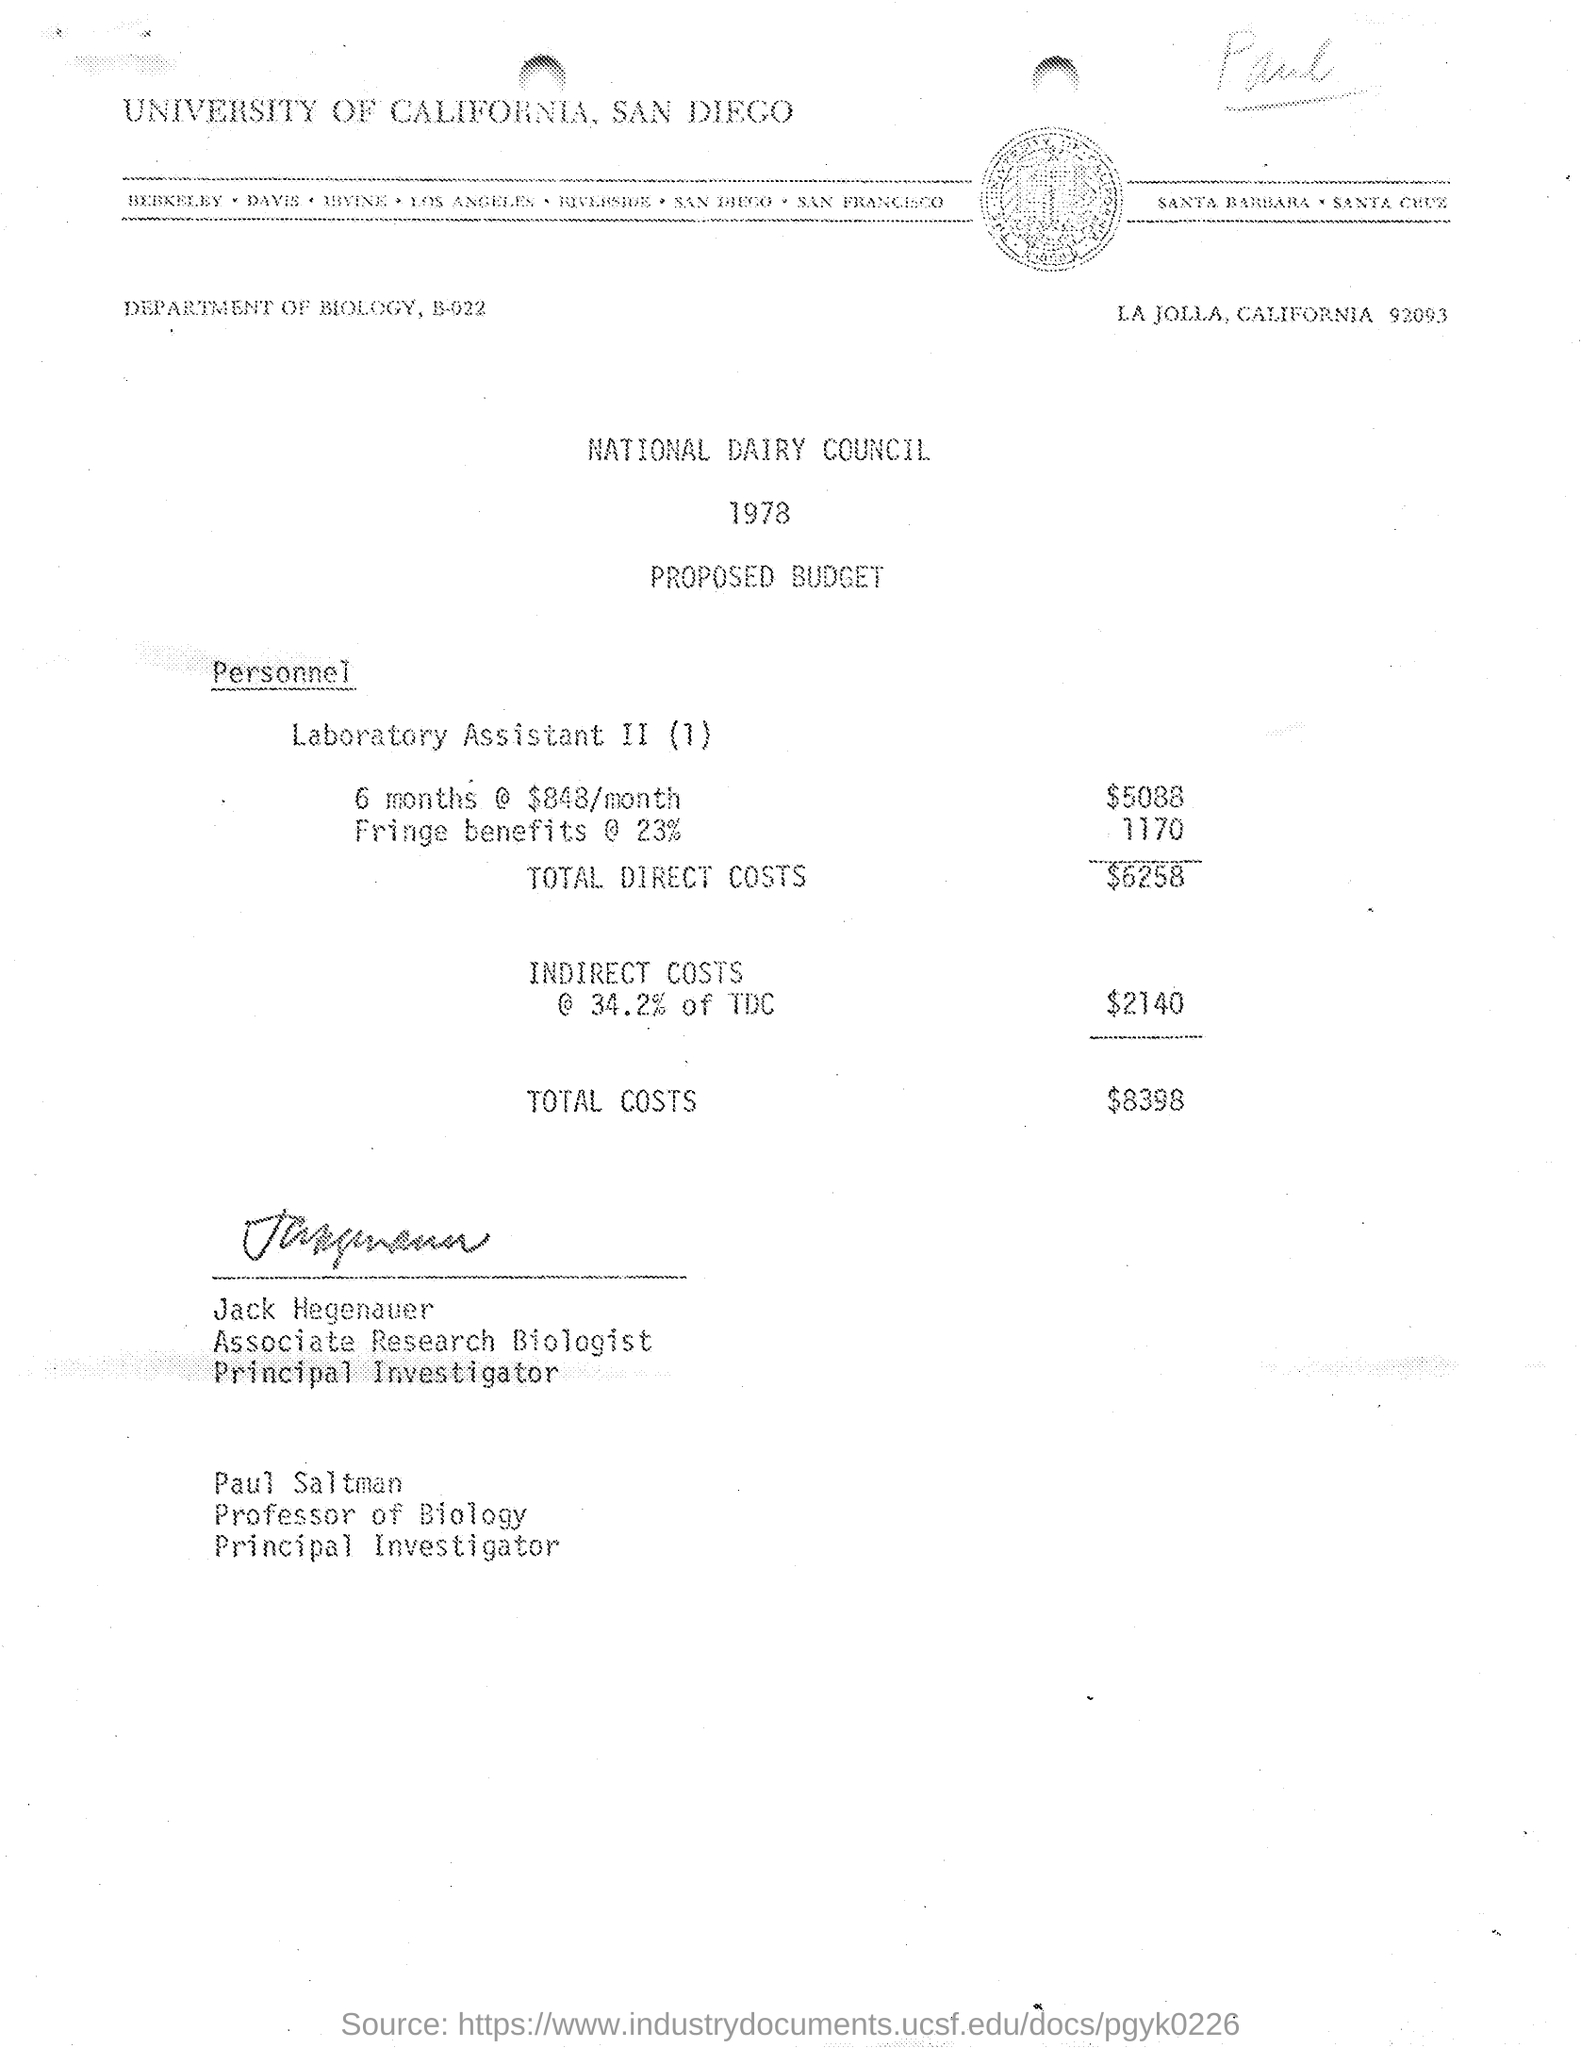Year in which this budget was proposed?
Offer a terse response. 1978. What is the budget for Laboratory Assistants for 6 months?
Give a very brief answer. $5088. What is the monthly paid amount?
Your answer should be very brief. $848/month. What is the percentage of Fringe benefit taken here?
Keep it short and to the point. 23%. Who was Associate Research Biologist?
Keep it short and to the point. Jack Hegenauer. 